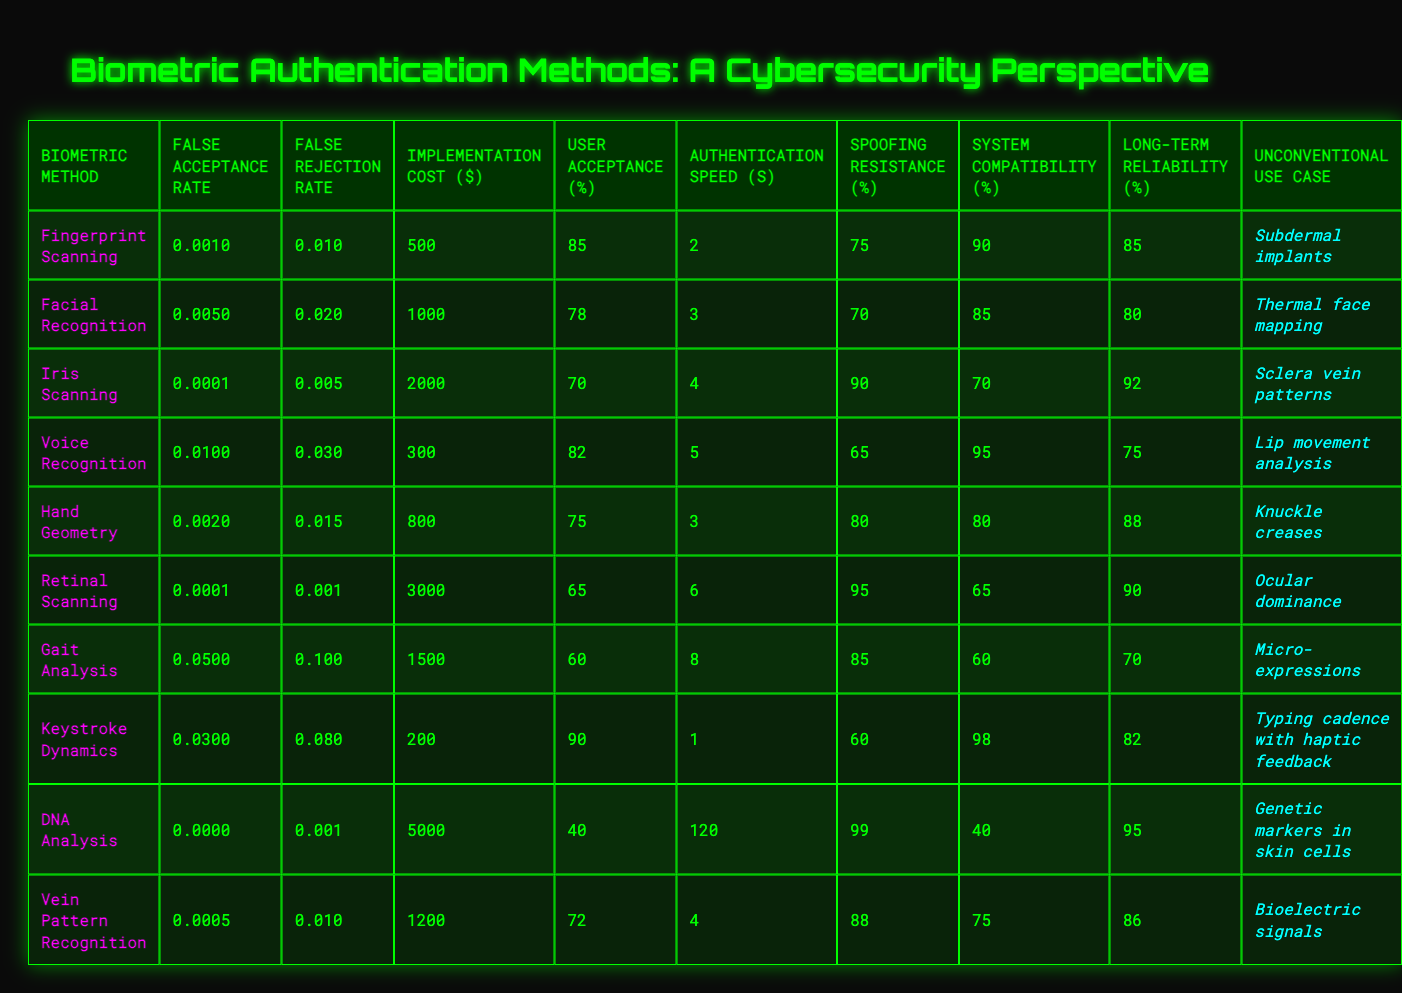What is the False Acceptance Rate for Iris Scanning? The table shows that the False Acceptance Rate for Iris Scanning is 0.0001.
Answer: 0.0001 Which biometric method has the highest User Acceptance? From the table, Keystroke Dynamics has the highest User Acceptance percentage at 90%.
Answer: 90% What is the average Implementation Cost of the biometric methods? To find the average, we sum the Implementation Costs: (500 + 1000 + 2000 + 300 + 800 + 3000 + 1500 + 200 + 5000 + 1200) = 15700, and divide by 10 to get 1570.
Answer: 1570 Is the False Rejection Rate for Voice Recognition greater than 0.02? The False Rejection Rate for Voice Recognition is 0.03, which is greater than 0.02.
Answer: Yes Which biometric method has the best Resistance to Spoofing? Evaluating the Resistance to Spoofing values, DNA Analysis has the highest score at 99%.
Answer: 99% How much higher is the Implementation Cost of Retinal Scanning compared to Hand Geometry? The Implementation Cost for Retinal Scanning is 3000 and for Hand Geometry it is 800. The difference is 3000 - 800 = 2200.
Answer: 2200 What is the total User Acceptance percentage for all biometric methods combined? Summing the User Acceptance percentages gives: (85 + 78 + 70 + 82 + 75 + 65 + 60 + 90 + 40 + 72) = 747.
Answer: 747 Which biometric methods have a Long-Term Reliability above 85%? The table indicates that Fingerprint Scanning, Iris Scanning, Retinal Scanning, DNA Analysis, and Vein Pattern Recognition have Long-Term Reliability percentages above 85%.
Answer: 5 methods What is the speed difference between the fastest and slowest biometric authentication methods? The fastest method is DNA Analysis with 120 seconds, and the slowest is Keystroke Dynamics with 1 second. The difference is 120 - 1 = 119 seconds.
Answer: 119 seconds Does Facial Recognition have a lower False Acceptance Rate than Voice Recognition? Facial Recognition has a False Acceptance Rate of 0.005, while Voice Recognition has a rate of 0.01, making Facial Recognition lower.
Answer: Yes 